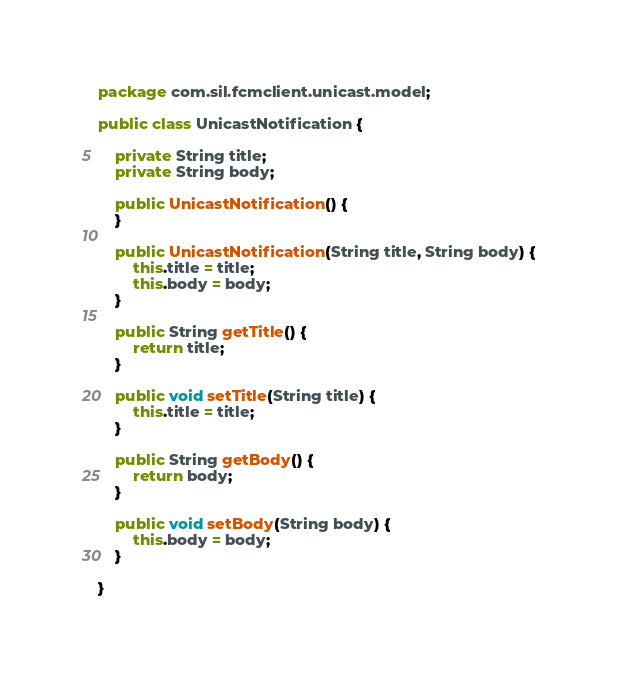Convert code to text. <code><loc_0><loc_0><loc_500><loc_500><_Java_>package com.sil.fcmclient.unicast.model;

public class UnicastNotification {

	private String title;
	private String body;

	public UnicastNotification() {
	}

	public UnicastNotification(String title, String body) {
		this.title = title;
		this.body = body;
	}

	public String getTitle() {
		return title;
	}

	public void setTitle(String title) {
		this.title = title;
	}

	public String getBody() {
		return body;
	}

	public void setBody(String body) {
		this.body = body;
	}

}
</code> 